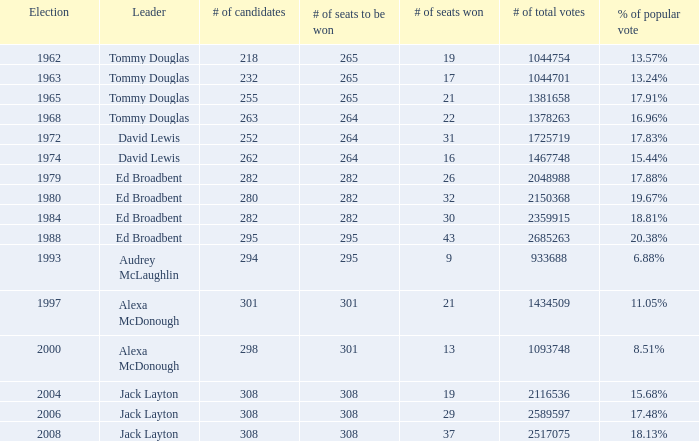State the overall votes for 30 victorious seats. 2359915.0. 